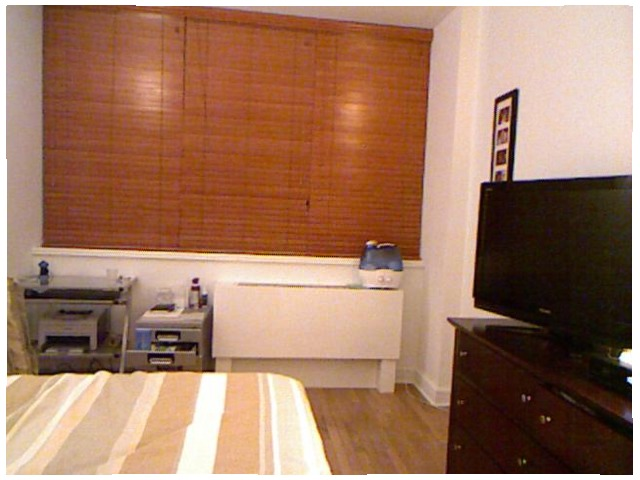<image>
Is there a table under the window? Yes. The table is positioned underneath the window, with the window above it in the vertical space. Is there a table to the left of the cupboard? Yes. From this viewpoint, the table is positioned to the left side relative to the cupboard. 